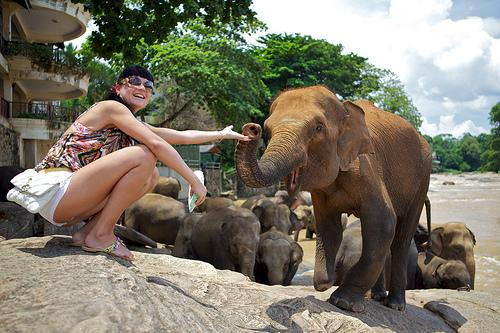Describe the setting where the image takes place. The image takes place near a river where a herd of elephants is gathered, with lush green trees, gray rocks, and a building with balconies in the background. What is the most significant object interaction present in the image? A young woman interacting with a brown elephant, possibly touching its trunk or feeding it. Rate the image quality on a scale of one to ten (1 being the worst, 10 being the best). 7, as the objects are clearly visible, but some details might be improved for better understanding. Count how many elephants can be seen in the image. There are at least five elephants in the image, with one being a baby elephant. Identify the primary activity taking place in the image and the main participant. A young woman is getting close to an elephant, seemingly feeding it or touching its trunk. Analyze the relationship between the elephants and their environment in the image. The elephants seem to be part of a herd near water, possibly playing in the river and interacting with their surroundings, including the young woman present. Discuss the possible intention of the woman in the image. The woman may be trying to experience a close encounter with the elephants, possibly feeding them or simply touching their trunks to establish a connection. Determine if the woman in the image is wearing any distinctive clothing or accessories. The woman is wearing sunglasses, a printed top, white shorts, flip flops, and a white purse. She also has a bracelet on her wrist. List the primary colors and elements found in the image. Brown elephants, gray rocks, green trees, blue sky, white clouds, a woman in white shorts, a building with balconies. What sentiment does the image evoke, and why? The image evokes a sense of wonder and connection with nature because of the close interaction between a young woman and an elephant. To the wondrous creature she does bring, In a chance meeting that makes her heart sing. Where are the balconies located in the scene? On a building behind the woman Create a poem about the woman and the baby elephant. In a peaceful scene by water's brink, Write a descriptive caption for the scene involving the woman and the baby elephant. A young woman wearing sunglasses and white shorts kneels on a gray rock while feeding a baby elephant as a herd of elephants gather near the water behind them. Based on the scene, do you think the woman is enjoying her encounter with the elephant? Yes, she appears to be enjoying the encounter with the elephant. Identify the main focal point of this image, and describe the interactions taking place. A young woman is getting close to and touching a baby elephant, feeding it peanuts. What is the primary event happening in the scene? A woman interacting and feeding a baby elephant What type of footwear is the woman wearing? Flip flops Can you spot any facial features on the baby elephant? If so, which ones are visible? The trunk and part of the nose of the elephant are visible. What are the dominant colors in the sky in the image? Blue and white How many elephants can be seen in the image, including the baby elephant? There are several elephants, including the baby elephant, as part of a herd near the water. Are the elephants enjoying their time with the woman? It seems so, as the baby elephant is willingly eating from the lady's hand. In your own words, describe the print on the woman's shirt. The woman's shirt has a light printed design. What's the scenery behind the herd of elephants? Trees with green leaves, a river, a building with balconies, and a blue sky with white clouds Describe the relationship between the woman and the baby elephant at this moment. The woman is attempting to build a friendly connection by offering food to the baby elephant. What is the woman doing with the brick-like object she is holding? Feeding the elephant a bag of peanuts Describe the emotions expressed by the woman in the image. The woman is smiling What is the woman carrying with her, and what color is it? A white purse Choose the correct statement: a) the woman is wearing sunglasses, b) the woman is wearing a hat, c) the woman is wearing a scarf. a) the woman is wearing sunglasses 